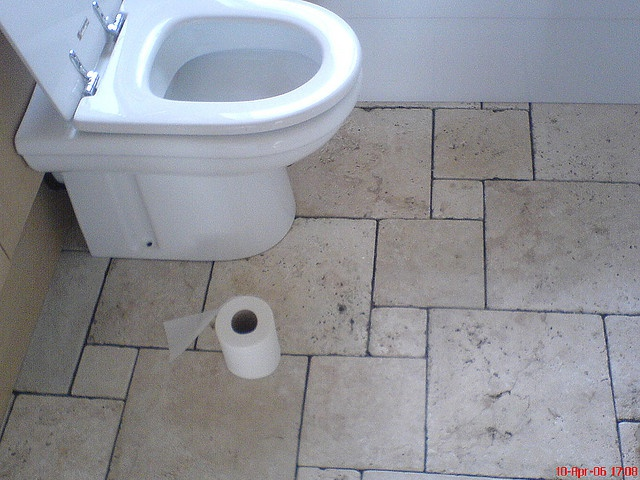Describe the objects in this image and their specific colors. I can see a toilet in lavender, darkgray, white, and lightblue tones in this image. 